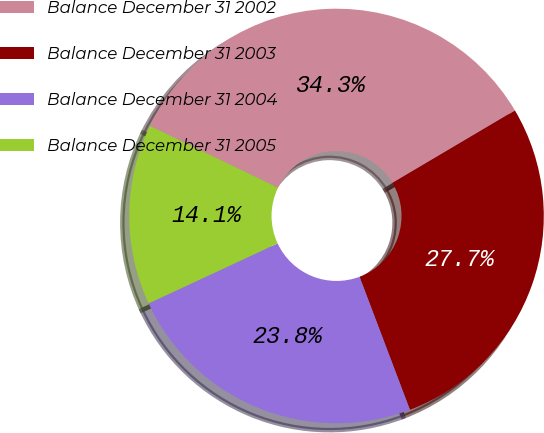<chart> <loc_0><loc_0><loc_500><loc_500><pie_chart><fcel>Balance December 31 2002<fcel>Balance December 31 2003<fcel>Balance December 31 2004<fcel>Balance December 31 2005<nl><fcel>34.34%<fcel>27.74%<fcel>23.83%<fcel>14.09%<nl></chart> 